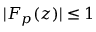Convert formula to latex. <formula><loc_0><loc_0><loc_500><loc_500>| F _ { p } ( z ) | \leq 1</formula> 